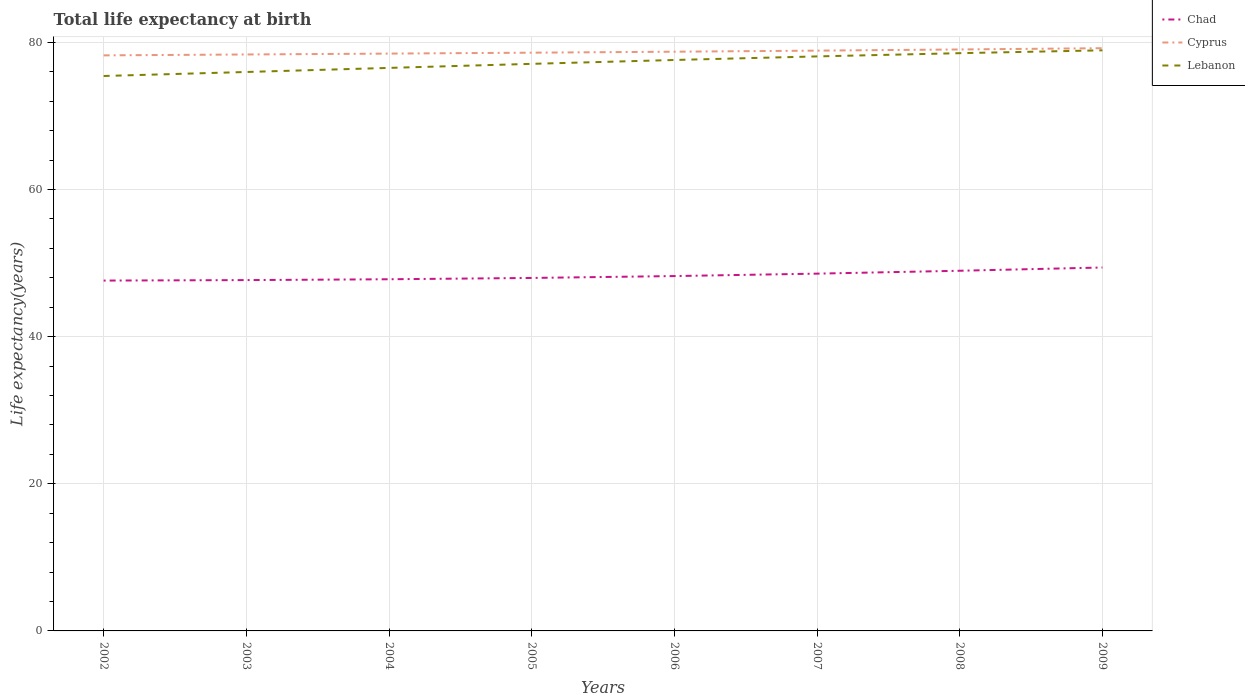Across all years, what is the maximum life expectancy at birth in in Lebanon?
Make the answer very short. 75.42. In which year was the life expectancy at birth in in Chad maximum?
Keep it short and to the point. 2002. What is the total life expectancy at birth in in Cyprus in the graph?
Keep it short and to the point. -0.85. What is the difference between the highest and the second highest life expectancy at birth in in Chad?
Your answer should be very brief. 1.78. What is the difference between the highest and the lowest life expectancy at birth in in Chad?
Keep it short and to the point. 3. Is the life expectancy at birth in in Lebanon strictly greater than the life expectancy at birth in in Cyprus over the years?
Offer a terse response. Yes. How many lines are there?
Keep it short and to the point. 3. What is the difference between two consecutive major ticks on the Y-axis?
Provide a short and direct response. 20. Where does the legend appear in the graph?
Offer a terse response. Top right. What is the title of the graph?
Your answer should be very brief. Total life expectancy at birth. Does "Cuba" appear as one of the legend labels in the graph?
Make the answer very short. No. What is the label or title of the Y-axis?
Keep it short and to the point. Life expectancy(years). What is the Life expectancy(years) in Chad in 2002?
Provide a short and direct response. 47.62. What is the Life expectancy(years) in Cyprus in 2002?
Your answer should be very brief. 78.22. What is the Life expectancy(years) in Lebanon in 2002?
Your answer should be compact. 75.42. What is the Life expectancy(years) of Chad in 2003?
Your answer should be very brief. 47.68. What is the Life expectancy(years) in Cyprus in 2003?
Provide a short and direct response. 78.35. What is the Life expectancy(years) of Lebanon in 2003?
Your answer should be very brief. 75.97. What is the Life expectancy(years) of Chad in 2004?
Ensure brevity in your answer.  47.8. What is the Life expectancy(years) of Cyprus in 2004?
Ensure brevity in your answer.  78.47. What is the Life expectancy(years) in Lebanon in 2004?
Your response must be concise. 76.52. What is the Life expectancy(years) of Chad in 2005?
Provide a short and direct response. 47.97. What is the Life expectancy(years) of Cyprus in 2005?
Your answer should be very brief. 78.59. What is the Life expectancy(years) of Lebanon in 2005?
Your answer should be compact. 77.07. What is the Life expectancy(years) of Chad in 2006?
Give a very brief answer. 48.23. What is the Life expectancy(years) of Cyprus in 2006?
Ensure brevity in your answer.  78.72. What is the Life expectancy(years) of Lebanon in 2006?
Give a very brief answer. 77.6. What is the Life expectancy(years) in Chad in 2007?
Ensure brevity in your answer.  48.56. What is the Life expectancy(years) of Cyprus in 2007?
Your answer should be very brief. 78.87. What is the Life expectancy(years) in Lebanon in 2007?
Make the answer very short. 78.08. What is the Life expectancy(years) of Chad in 2008?
Provide a succinct answer. 48.95. What is the Life expectancy(years) in Cyprus in 2008?
Your answer should be very brief. 79.03. What is the Life expectancy(years) of Lebanon in 2008?
Keep it short and to the point. 78.52. What is the Life expectancy(years) in Chad in 2009?
Provide a succinct answer. 49.39. What is the Life expectancy(years) in Cyprus in 2009?
Your response must be concise. 79.2. What is the Life expectancy(years) in Lebanon in 2009?
Ensure brevity in your answer.  78.91. Across all years, what is the maximum Life expectancy(years) in Chad?
Provide a succinct answer. 49.39. Across all years, what is the maximum Life expectancy(years) in Cyprus?
Make the answer very short. 79.2. Across all years, what is the maximum Life expectancy(years) of Lebanon?
Keep it short and to the point. 78.91. Across all years, what is the minimum Life expectancy(years) in Chad?
Offer a terse response. 47.62. Across all years, what is the minimum Life expectancy(years) of Cyprus?
Your response must be concise. 78.22. Across all years, what is the minimum Life expectancy(years) in Lebanon?
Keep it short and to the point. 75.42. What is the total Life expectancy(years) in Chad in the graph?
Offer a terse response. 386.2. What is the total Life expectancy(years) in Cyprus in the graph?
Your answer should be very brief. 629.44. What is the total Life expectancy(years) in Lebanon in the graph?
Offer a terse response. 618.09. What is the difference between the Life expectancy(years) of Chad in 2002 and that in 2003?
Provide a short and direct response. -0.07. What is the difference between the Life expectancy(years) in Cyprus in 2002 and that in 2003?
Your response must be concise. -0.12. What is the difference between the Life expectancy(years) in Lebanon in 2002 and that in 2003?
Keep it short and to the point. -0.55. What is the difference between the Life expectancy(years) of Chad in 2002 and that in 2004?
Give a very brief answer. -0.18. What is the difference between the Life expectancy(years) of Cyprus in 2002 and that in 2004?
Make the answer very short. -0.24. What is the difference between the Life expectancy(years) of Lebanon in 2002 and that in 2004?
Offer a terse response. -1.1. What is the difference between the Life expectancy(years) of Chad in 2002 and that in 2005?
Provide a short and direct response. -0.36. What is the difference between the Life expectancy(years) in Cyprus in 2002 and that in 2005?
Keep it short and to the point. -0.37. What is the difference between the Life expectancy(years) in Lebanon in 2002 and that in 2005?
Ensure brevity in your answer.  -1.65. What is the difference between the Life expectancy(years) in Chad in 2002 and that in 2006?
Your answer should be very brief. -0.61. What is the difference between the Life expectancy(years) of Cyprus in 2002 and that in 2006?
Provide a succinct answer. -0.5. What is the difference between the Life expectancy(years) of Lebanon in 2002 and that in 2006?
Provide a short and direct response. -2.18. What is the difference between the Life expectancy(years) of Chad in 2002 and that in 2007?
Provide a short and direct response. -0.94. What is the difference between the Life expectancy(years) of Cyprus in 2002 and that in 2007?
Your answer should be compact. -0.64. What is the difference between the Life expectancy(years) of Lebanon in 2002 and that in 2007?
Ensure brevity in your answer.  -2.66. What is the difference between the Life expectancy(years) of Chad in 2002 and that in 2008?
Offer a terse response. -1.34. What is the difference between the Life expectancy(years) in Cyprus in 2002 and that in 2008?
Your answer should be compact. -0.8. What is the difference between the Life expectancy(years) of Lebanon in 2002 and that in 2008?
Provide a short and direct response. -3.1. What is the difference between the Life expectancy(years) in Chad in 2002 and that in 2009?
Keep it short and to the point. -1.78. What is the difference between the Life expectancy(years) in Cyprus in 2002 and that in 2009?
Make the answer very short. -0.98. What is the difference between the Life expectancy(years) of Lebanon in 2002 and that in 2009?
Provide a short and direct response. -3.49. What is the difference between the Life expectancy(years) in Chad in 2003 and that in 2004?
Make the answer very short. -0.11. What is the difference between the Life expectancy(years) in Cyprus in 2003 and that in 2004?
Your answer should be compact. -0.12. What is the difference between the Life expectancy(years) of Lebanon in 2003 and that in 2004?
Keep it short and to the point. -0.56. What is the difference between the Life expectancy(years) in Chad in 2003 and that in 2005?
Ensure brevity in your answer.  -0.29. What is the difference between the Life expectancy(years) in Cyprus in 2003 and that in 2005?
Keep it short and to the point. -0.24. What is the difference between the Life expectancy(years) in Lebanon in 2003 and that in 2005?
Give a very brief answer. -1.11. What is the difference between the Life expectancy(years) in Chad in 2003 and that in 2006?
Offer a very short reply. -0.55. What is the difference between the Life expectancy(years) in Cyprus in 2003 and that in 2006?
Provide a succinct answer. -0.38. What is the difference between the Life expectancy(years) of Lebanon in 2003 and that in 2006?
Offer a very short reply. -1.63. What is the difference between the Life expectancy(years) of Chad in 2003 and that in 2007?
Your answer should be compact. -0.88. What is the difference between the Life expectancy(years) in Cyprus in 2003 and that in 2007?
Your answer should be compact. -0.52. What is the difference between the Life expectancy(years) of Lebanon in 2003 and that in 2007?
Ensure brevity in your answer.  -2.12. What is the difference between the Life expectancy(years) in Chad in 2003 and that in 2008?
Offer a very short reply. -1.27. What is the difference between the Life expectancy(years) of Cyprus in 2003 and that in 2008?
Keep it short and to the point. -0.68. What is the difference between the Life expectancy(years) in Lebanon in 2003 and that in 2008?
Offer a very short reply. -2.56. What is the difference between the Life expectancy(years) of Chad in 2003 and that in 2009?
Offer a very short reply. -1.71. What is the difference between the Life expectancy(years) of Cyprus in 2003 and that in 2009?
Provide a succinct answer. -0.85. What is the difference between the Life expectancy(years) of Lebanon in 2003 and that in 2009?
Give a very brief answer. -2.94. What is the difference between the Life expectancy(years) of Chad in 2004 and that in 2005?
Make the answer very short. -0.18. What is the difference between the Life expectancy(years) in Cyprus in 2004 and that in 2005?
Give a very brief answer. -0.12. What is the difference between the Life expectancy(years) of Lebanon in 2004 and that in 2005?
Offer a very short reply. -0.55. What is the difference between the Life expectancy(years) in Chad in 2004 and that in 2006?
Keep it short and to the point. -0.43. What is the difference between the Life expectancy(years) of Cyprus in 2004 and that in 2006?
Your answer should be very brief. -0.26. What is the difference between the Life expectancy(years) of Lebanon in 2004 and that in 2006?
Give a very brief answer. -1.08. What is the difference between the Life expectancy(years) in Chad in 2004 and that in 2007?
Make the answer very short. -0.76. What is the difference between the Life expectancy(years) in Cyprus in 2004 and that in 2007?
Provide a succinct answer. -0.4. What is the difference between the Life expectancy(years) of Lebanon in 2004 and that in 2007?
Offer a terse response. -1.56. What is the difference between the Life expectancy(years) of Chad in 2004 and that in 2008?
Make the answer very short. -1.16. What is the difference between the Life expectancy(years) in Cyprus in 2004 and that in 2008?
Offer a terse response. -0.56. What is the difference between the Life expectancy(years) in Lebanon in 2004 and that in 2008?
Give a very brief answer. -2. What is the difference between the Life expectancy(years) in Chad in 2004 and that in 2009?
Your response must be concise. -1.6. What is the difference between the Life expectancy(years) of Cyprus in 2004 and that in 2009?
Provide a short and direct response. -0.73. What is the difference between the Life expectancy(years) in Lebanon in 2004 and that in 2009?
Provide a short and direct response. -2.39. What is the difference between the Life expectancy(years) in Chad in 2005 and that in 2006?
Ensure brevity in your answer.  -0.26. What is the difference between the Life expectancy(years) in Cyprus in 2005 and that in 2006?
Your answer should be compact. -0.13. What is the difference between the Life expectancy(years) of Lebanon in 2005 and that in 2006?
Provide a short and direct response. -0.53. What is the difference between the Life expectancy(years) in Chad in 2005 and that in 2007?
Ensure brevity in your answer.  -0.59. What is the difference between the Life expectancy(years) in Cyprus in 2005 and that in 2007?
Provide a succinct answer. -0.28. What is the difference between the Life expectancy(years) in Lebanon in 2005 and that in 2007?
Offer a very short reply. -1.01. What is the difference between the Life expectancy(years) in Chad in 2005 and that in 2008?
Give a very brief answer. -0.98. What is the difference between the Life expectancy(years) in Cyprus in 2005 and that in 2008?
Offer a terse response. -0.44. What is the difference between the Life expectancy(years) of Lebanon in 2005 and that in 2008?
Make the answer very short. -1.45. What is the difference between the Life expectancy(years) in Chad in 2005 and that in 2009?
Make the answer very short. -1.42. What is the difference between the Life expectancy(years) in Cyprus in 2005 and that in 2009?
Your answer should be very brief. -0.61. What is the difference between the Life expectancy(years) in Lebanon in 2005 and that in 2009?
Offer a very short reply. -1.84. What is the difference between the Life expectancy(years) in Chad in 2006 and that in 2007?
Ensure brevity in your answer.  -0.33. What is the difference between the Life expectancy(years) in Cyprus in 2006 and that in 2007?
Your answer should be compact. -0.15. What is the difference between the Life expectancy(years) in Lebanon in 2006 and that in 2007?
Provide a short and direct response. -0.49. What is the difference between the Life expectancy(years) of Chad in 2006 and that in 2008?
Provide a short and direct response. -0.72. What is the difference between the Life expectancy(years) of Cyprus in 2006 and that in 2008?
Give a very brief answer. -0.3. What is the difference between the Life expectancy(years) in Lebanon in 2006 and that in 2008?
Keep it short and to the point. -0.93. What is the difference between the Life expectancy(years) of Chad in 2006 and that in 2009?
Offer a terse response. -1.16. What is the difference between the Life expectancy(years) of Cyprus in 2006 and that in 2009?
Your answer should be very brief. -0.48. What is the difference between the Life expectancy(years) in Lebanon in 2006 and that in 2009?
Keep it short and to the point. -1.31. What is the difference between the Life expectancy(years) of Chad in 2007 and that in 2008?
Your answer should be compact. -0.39. What is the difference between the Life expectancy(years) of Cyprus in 2007 and that in 2008?
Your answer should be very brief. -0.16. What is the difference between the Life expectancy(years) of Lebanon in 2007 and that in 2008?
Your answer should be very brief. -0.44. What is the difference between the Life expectancy(years) of Chad in 2007 and that in 2009?
Offer a very short reply. -0.83. What is the difference between the Life expectancy(years) of Cyprus in 2007 and that in 2009?
Provide a succinct answer. -0.33. What is the difference between the Life expectancy(years) of Lebanon in 2007 and that in 2009?
Offer a very short reply. -0.83. What is the difference between the Life expectancy(years) of Chad in 2008 and that in 2009?
Keep it short and to the point. -0.44. What is the difference between the Life expectancy(years) of Cyprus in 2008 and that in 2009?
Your response must be concise. -0.17. What is the difference between the Life expectancy(years) of Lebanon in 2008 and that in 2009?
Make the answer very short. -0.39. What is the difference between the Life expectancy(years) in Chad in 2002 and the Life expectancy(years) in Cyprus in 2003?
Offer a terse response. -30.73. What is the difference between the Life expectancy(years) in Chad in 2002 and the Life expectancy(years) in Lebanon in 2003?
Provide a succinct answer. -28.35. What is the difference between the Life expectancy(years) in Cyprus in 2002 and the Life expectancy(years) in Lebanon in 2003?
Offer a very short reply. 2.26. What is the difference between the Life expectancy(years) of Chad in 2002 and the Life expectancy(years) of Cyprus in 2004?
Ensure brevity in your answer.  -30.85. What is the difference between the Life expectancy(years) of Chad in 2002 and the Life expectancy(years) of Lebanon in 2004?
Make the answer very short. -28.91. What is the difference between the Life expectancy(years) in Cyprus in 2002 and the Life expectancy(years) in Lebanon in 2004?
Ensure brevity in your answer.  1.7. What is the difference between the Life expectancy(years) in Chad in 2002 and the Life expectancy(years) in Cyprus in 2005?
Keep it short and to the point. -30.97. What is the difference between the Life expectancy(years) of Chad in 2002 and the Life expectancy(years) of Lebanon in 2005?
Your answer should be compact. -29.46. What is the difference between the Life expectancy(years) in Cyprus in 2002 and the Life expectancy(years) in Lebanon in 2005?
Your answer should be very brief. 1.15. What is the difference between the Life expectancy(years) of Chad in 2002 and the Life expectancy(years) of Cyprus in 2006?
Ensure brevity in your answer.  -31.11. What is the difference between the Life expectancy(years) of Chad in 2002 and the Life expectancy(years) of Lebanon in 2006?
Your answer should be very brief. -29.98. What is the difference between the Life expectancy(years) in Cyprus in 2002 and the Life expectancy(years) in Lebanon in 2006?
Give a very brief answer. 0.63. What is the difference between the Life expectancy(years) in Chad in 2002 and the Life expectancy(years) in Cyprus in 2007?
Your answer should be compact. -31.25. What is the difference between the Life expectancy(years) of Chad in 2002 and the Life expectancy(years) of Lebanon in 2007?
Offer a very short reply. -30.47. What is the difference between the Life expectancy(years) of Cyprus in 2002 and the Life expectancy(years) of Lebanon in 2007?
Make the answer very short. 0.14. What is the difference between the Life expectancy(years) in Chad in 2002 and the Life expectancy(years) in Cyprus in 2008?
Your response must be concise. -31.41. What is the difference between the Life expectancy(years) of Chad in 2002 and the Life expectancy(years) of Lebanon in 2008?
Ensure brevity in your answer.  -30.91. What is the difference between the Life expectancy(years) of Cyprus in 2002 and the Life expectancy(years) of Lebanon in 2008?
Your answer should be compact. -0.3. What is the difference between the Life expectancy(years) in Chad in 2002 and the Life expectancy(years) in Cyprus in 2009?
Your response must be concise. -31.58. What is the difference between the Life expectancy(years) in Chad in 2002 and the Life expectancy(years) in Lebanon in 2009?
Offer a terse response. -31.29. What is the difference between the Life expectancy(years) in Cyprus in 2002 and the Life expectancy(years) in Lebanon in 2009?
Keep it short and to the point. -0.69. What is the difference between the Life expectancy(years) in Chad in 2003 and the Life expectancy(years) in Cyprus in 2004?
Offer a very short reply. -30.78. What is the difference between the Life expectancy(years) of Chad in 2003 and the Life expectancy(years) of Lebanon in 2004?
Provide a short and direct response. -28.84. What is the difference between the Life expectancy(years) in Cyprus in 2003 and the Life expectancy(years) in Lebanon in 2004?
Keep it short and to the point. 1.82. What is the difference between the Life expectancy(years) of Chad in 2003 and the Life expectancy(years) of Cyprus in 2005?
Provide a succinct answer. -30.91. What is the difference between the Life expectancy(years) of Chad in 2003 and the Life expectancy(years) of Lebanon in 2005?
Give a very brief answer. -29.39. What is the difference between the Life expectancy(years) of Cyprus in 2003 and the Life expectancy(years) of Lebanon in 2005?
Keep it short and to the point. 1.27. What is the difference between the Life expectancy(years) of Chad in 2003 and the Life expectancy(years) of Cyprus in 2006?
Offer a very short reply. -31.04. What is the difference between the Life expectancy(years) in Chad in 2003 and the Life expectancy(years) in Lebanon in 2006?
Keep it short and to the point. -29.91. What is the difference between the Life expectancy(years) in Cyprus in 2003 and the Life expectancy(years) in Lebanon in 2006?
Your response must be concise. 0.75. What is the difference between the Life expectancy(years) of Chad in 2003 and the Life expectancy(years) of Cyprus in 2007?
Make the answer very short. -31.19. What is the difference between the Life expectancy(years) of Chad in 2003 and the Life expectancy(years) of Lebanon in 2007?
Offer a terse response. -30.4. What is the difference between the Life expectancy(years) in Cyprus in 2003 and the Life expectancy(years) in Lebanon in 2007?
Ensure brevity in your answer.  0.26. What is the difference between the Life expectancy(years) of Chad in 2003 and the Life expectancy(years) of Cyprus in 2008?
Make the answer very short. -31.35. What is the difference between the Life expectancy(years) of Chad in 2003 and the Life expectancy(years) of Lebanon in 2008?
Offer a very short reply. -30.84. What is the difference between the Life expectancy(years) of Cyprus in 2003 and the Life expectancy(years) of Lebanon in 2008?
Give a very brief answer. -0.18. What is the difference between the Life expectancy(years) in Chad in 2003 and the Life expectancy(years) in Cyprus in 2009?
Your response must be concise. -31.52. What is the difference between the Life expectancy(years) in Chad in 2003 and the Life expectancy(years) in Lebanon in 2009?
Give a very brief answer. -31.23. What is the difference between the Life expectancy(years) of Cyprus in 2003 and the Life expectancy(years) of Lebanon in 2009?
Your answer should be very brief. -0.56. What is the difference between the Life expectancy(years) in Chad in 2004 and the Life expectancy(years) in Cyprus in 2005?
Your answer should be very brief. -30.79. What is the difference between the Life expectancy(years) in Chad in 2004 and the Life expectancy(years) in Lebanon in 2005?
Offer a terse response. -29.28. What is the difference between the Life expectancy(years) in Cyprus in 2004 and the Life expectancy(years) in Lebanon in 2005?
Give a very brief answer. 1.39. What is the difference between the Life expectancy(years) in Chad in 2004 and the Life expectancy(years) in Cyprus in 2006?
Keep it short and to the point. -30.93. What is the difference between the Life expectancy(years) in Chad in 2004 and the Life expectancy(years) in Lebanon in 2006?
Your answer should be compact. -29.8. What is the difference between the Life expectancy(years) of Cyprus in 2004 and the Life expectancy(years) of Lebanon in 2006?
Provide a short and direct response. 0.87. What is the difference between the Life expectancy(years) in Chad in 2004 and the Life expectancy(years) in Cyprus in 2007?
Your answer should be compact. -31.07. What is the difference between the Life expectancy(years) of Chad in 2004 and the Life expectancy(years) of Lebanon in 2007?
Offer a very short reply. -30.29. What is the difference between the Life expectancy(years) in Cyprus in 2004 and the Life expectancy(years) in Lebanon in 2007?
Offer a very short reply. 0.38. What is the difference between the Life expectancy(years) in Chad in 2004 and the Life expectancy(years) in Cyprus in 2008?
Make the answer very short. -31.23. What is the difference between the Life expectancy(years) in Chad in 2004 and the Life expectancy(years) in Lebanon in 2008?
Your answer should be very brief. -30.73. What is the difference between the Life expectancy(years) of Cyprus in 2004 and the Life expectancy(years) of Lebanon in 2008?
Give a very brief answer. -0.06. What is the difference between the Life expectancy(years) of Chad in 2004 and the Life expectancy(years) of Cyprus in 2009?
Provide a short and direct response. -31.4. What is the difference between the Life expectancy(years) in Chad in 2004 and the Life expectancy(years) in Lebanon in 2009?
Provide a succinct answer. -31.11. What is the difference between the Life expectancy(years) in Cyprus in 2004 and the Life expectancy(years) in Lebanon in 2009?
Keep it short and to the point. -0.44. What is the difference between the Life expectancy(years) in Chad in 2005 and the Life expectancy(years) in Cyprus in 2006?
Your answer should be compact. -30.75. What is the difference between the Life expectancy(years) in Chad in 2005 and the Life expectancy(years) in Lebanon in 2006?
Provide a short and direct response. -29.62. What is the difference between the Life expectancy(years) of Chad in 2005 and the Life expectancy(years) of Cyprus in 2007?
Ensure brevity in your answer.  -30.89. What is the difference between the Life expectancy(years) in Chad in 2005 and the Life expectancy(years) in Lebanon in 2007?
Your response must be concise. -30.11. What is the difference between the Life expectancy(years) of Cyprus in 2005 and the Life expectancy(years) of Lebanon in 2007?
Your answer should be very brief. 0.51. What is the difference between the Life expectancy(years) in Chad in 2005 and the Life expectancy(years) in Cyprus in 2008?
Your answer should be compact. -31.05. What is the difference between the Life expectancy(years) in Chad in 2005 and the Life expectancy(years) in Lebanon in 2008?
Keep it short and to the point. -30.55. What is the difference between the Life expectancy(years) of Cyprus in 2005 and the Life expectancy(years) of Lebanon in 2008?
Make the answer very short. 0.07. What is the difference between the Life expectancy(years) in Chad in 2005 and the Life expectancy(years) in Cyprus in 2009?
Your answer should be compact. -31.23. What is the difference between the Life expectancy(years) in Chad in 2005 and the Life expectancy(years) in Lebanon in 2009?
Offer a terse response. -30.94. What is the difference between the Life expectancy(years) in Cyprus in 2005 and the Life expectancy(years) in Lebanon in 2009?
Offer a terse response. -0.32. What is the difference between the Life expectancy(years) in Chad in 2006 and the Life expectancy(years) in Cyprus in 2007?
Offer a very short reply. -30.64. What is the difference between the Life expectancy(years) of Chad in 2006 and the Life expectancy(years) of Lebanon in 2007?
Give a very brief answer. -29.85. What is the difference between the Life expectancy(years) of Cyprus in 2006 and the Life expectancy(years) of Lebanon in 2007?
Your answer should be very brief. 0.64. What is the difference between the Life expectancy(years) of Chad in 2006 and the Life expectancy(years) of Cyprus in 2008?
Your answer should be very brief. -30.8. What is the difference between the Life expectancy(years) of Chad in 2006 and the Life expectancy(years) of Lebanon in 2008?
Provide a short and direct response. -30.29. What is the difference between the Life expectancy(years) in Cyprus in 2006 and the Life expectancy(years) in Lebanon in 2008?
Make the answer very short. 0.2. What is the difference between the Life expectancy(years) of Chad in 2006 and the Life expectancy(years) of Cyprus in 2009?
Your answer should be compact. -30.97. What is the difference between the Life expectancy(years) of Chad in 2006 and the Life expectancy(years) of Lebanon in 2009?
Your answer should be very brief. -30.68. What is the difference between the Life expectancy(years) of Cyprus in 2006 and the Life expectancy(years) of Lebanon in 2009?
Keep it short and to the point. -0.19. What is the difference between the Life expectancy(years) of Chad in 2007 and the Life expectancy(years) of Cyprus in 2008?
Your answer should be very brief. -30.47. What is the difference between the Life expectancy(years) of Chad in 2007 and the Life expectancy(years) of Lebanon in 2008?
Ensure brevity in your answer.  -29.96. What is the difference between the Life expectancy(years) of Cyprus in 2007 and the Life expectancy(years) of Lebanon in 2008?
Provide a succinct answer. 0.35. What is the difference between the Life expectancy(years) in Chad in 2007 and the Life expectancy(years) in Cyprus in 2009?
Provide a succinct answer. -30.64. What is the difference between the Life expectancy(years) of Chad in 2007 and the Life expectancy(years) of Lebanon in 2009?
Offer a very short reply. -30.35. What is the difference between the Life expectancy(years) in Cyprus in 2007 and the Life expectancy(years) in Lebanon in 2009?
Your answer should be compact. -0.04. What is the difference between the Life expectancy(years) of Chad in 2008 and the Life expectancy(years) of Cyprus in 2009?
Give a very brief answer. -30.25. What is the difference between the Life expectancy(years) of Chad in 2008 and the Life expectancy(years) of Lebanon in 2009?
Give a very brief answer. -29.96. What is the difference between the Life expectancy(years) in Cyprus in 2008 and the Life expectancy(years) in Lebanon in 2009?
Provide a succinct answer. 0.12. What is the average Life expectancy(years) in Chad per year?
Offer a very short reply. 48.28. What is the average Life expectancy(years) of Cyprus per year?
Your answer should be compact. 78.68. What is the average Life expectancy(years) of Lebanon per year?
Your answer should be very brief. 77.26. In the year 2002, what is the difference between the Life expectancy(years) of Chad and Life expectancy(years) of Cyprus?
Provide a short and direct response. -30.61. In the year 2002, what is the difference between the Life expectancy(years) in Chad and Life expectancy(years) in Lebanon?
Make the answer very short. -27.81. In the year 2002, what is the difference between the Life expectancy(years) in Cyprus and Life expectancy(years) in Lebanon?
Ensure brevity in your answer.  2.8. In the year 2003, what is the difference between the Life expectancy(years) in Chad and Life expectancy(years) in Cyprus?
Make the answer very short. -30.66. In the year 2003, what is the difference between the Life expectancy(years) of Chad and Life expectancy(years) of Lebanon?
Your response must be concise. -28.28. In the year 2003, what is the difference between the Life expectancy(years) in Cyprus and Life expectancy(years) in Lebanon?
Ensure brevity in your answer.  2.38. In the year 2004, what is the difference between the Life expectancy(years) of Chad and Life expectancy(years) of Cyprus?
Your response must be concise. -30.67. In the year 2004, what is the difference between the Life expectancy(years) of Chad and Life expectancy(years) of Lebanon?
Provide a succinct answer. -28.73. In the year 2004, what is the difference between the Life expectancy(years) of Cyprus and Life expectancy(years) of Lebanon?
Offer a very short reply. 1.94. In the year 2005, what is the difference between the Life expectancy(years) of Chad and Life expectancy(years) of Cyprus?
Give a very brief answer. -30.62. In the year 2005, what is the difference between the Life expectancy(years) of Chad and Life expectancy(years) of Lebanon?
Give a very brief answer. -29.1. In the year 2005, what is the difference between the Life expectancy(years) in Cyprus and Life expectancy(years) in Lebanon?
Give a very brief answer. 1.52. In the year 2006, what is the difference between the Life expectancy(years) in Chad and Life expectancy(years) in Cyprus?
Your answer should be very brief. -30.49. In the year 2006, what is the difference between the Life expectancy(years) in Chad and Life expectancy(years) in Lebanon?
Provide a succinct answer. -29.37. In the year 2006, what is the difference between the Life expectancy(years) of Cyprus and Life expectancy(years) of Lebanon?
Ensure brevity in your answer.  1.13. In the year 2007, what is the difference between the Life expectancy(years) in Chad and Life expectancy(years) in Cyprus?
Ensure brevity in your answer.  -30.31. In the year 2007, what is the difference between the Life expectancy(years) in Chad and Life expectancy(years) in Lebanon?
Provide a short and direct response. -29.52. In the year 2007, what is the difference between the Life expectancy(years) of Cyprus and Life expectancy(years) of Lebanon?
Your answer should be very brief. 0.79. In the year 2008, what is the difference between the Life expectancy(years) in Chad and Life expectancy(years) in Cyprus?
Your answer should be very brief. -30.08. In the year 2008, what is the difference between the Life expectancy(years) in Chad and Life expectancy(years) in Lebanon?
Your response must be concise. -29.57. In the year 2008, what is the difference between the Life expectancy(years) of Cyprus and Life expectancy(years) of Lebanon?
Offer a terse response. 0.51. In the year 2009, what is the difference between the Life expectancy(years) of Chad and Life expectancy(years) of Cyprus?
Make the answer very short. -29.81. In the year 2009, what is the difference between the Life expectancy(years) in Chad and Life expectancy(years) in Lebanon?
Your answer should be compact. -29.52. In the year 2009, what is the difference between the Life expectancy(years) in Cyprus and Life expectancy(years) in Lebanon?
Ensure brevity in your answer.  0.29. What is the ratio of the Life expectancy(years) of Lebanon in 2002 to that in 2004?
Provide a succinct answer. 0.99. What is the ratio of the Life expectancy(years) in Chad in 2002 to that in 2005?
Give a very brief answer. 0.99. What is the ratio of the Life expectancy(years) in Cyprus in 2002 to that in 2005?
Offer a terse response. 1. What is the ratio of the Life expectancy(years) in Lebanon in 2002 to that in 2005?
Make the answer very short. 0.98. What is the ratio of the Life expectancy(years) in Chad in 2002 to that in 2006?
Give a very brief answer. 0.99. What is the ratio of the Life expectancy(years) in Chad in 2002 to that in 2007?
Keep it short and to the point. 0.98. What is the ratio of the Life expectancy(years) of Cyprus in 2002 to that in 2007?
Make the answer very short. 0.99. What is the ratio of the Life expectancy(years) in Lebanon in 2002 to that in 2007?
Ensure brevity in your answer.  0.97. What is the ratio of the Life expectancy(years) in Chad in 2002 to that in 2008?
Ensure brevity in your answer.  0.97. What is the ratio of the Life expectancy(years) in Lebanon in 2002 to that in 2008?
Offer a very short reply. 0.96. What is the ratio of the Life expectancy(years) of Lebanon in 2002 to that in 2009?
Give a very brief answer. 0.96. What is the ratio of the Life expectancy(years) of Cyprus in 2003 to that in 2004?
Provide a short and direct response. 1. What is the ratio of the Life expectancy(years) in Lebanon in 2003 to that in 2004?
Keep it short and to the point. 0.99. What is the ratio of the Life expectancy(years) in Chad in 2003 to that in 2005?
Give a very brief answer. 0.99. What is the ratio of the Life expectancy(years) in Cyprus in 2003 to that in 2005?
Keep it short and to the point. 1. What is the ratio of the Life expectancy(years) of Lebanon in 2003 to that in 2005?
Provide a short and direct response. 0.99. What is the ratio of the Life expectancy(years) of Cyprus in 2003 to that in 2006?
Make the answer very short. 1. What is the ratio of the Life expectancy(years) in Lebanon in 2003 to that in 2006?
Your answer should be very brief. 0.98. What is the ratio of the Life expectancy(years) of Chad in 2003 to that in 2007?
Your response must be concise. 0.98. What is the ratio of the Life expectancy(years) of Cyprus in 2003 to that in 2007?
Provide a short and direct response. 0.99. What is the ratio of the Life expectancy(years) of Lebanon in 2003 to that in 2007?
Your answer should be very brief. 0.97. What is the ratio of the Life expectancy(years) in Chad in 2003 to that in 2008?
Provide a short and direct response. 0.97. What is the ratio of the Life expectancy(years) in Cyprus in 2003 to that in 2008?
Offer a terse response. 0.99. What is the ratio of the Life expectancy(years) of Lebanon in 2003 to that in 2008?
Provide a succinct answer. 0.97. What is the ratio of the Life expectancy(years) of Chad in 2003 to that in 2009?
Your answer should be very brief. 0.97. What is the ratio of the Life expectancy(years) in Cyprus in 2003 to that in 2009?
Your response must be concise. 0.99. What is the ratio of the Life expectancy(years) of Lebanon in 2003 to that in 2009?
Offer a very short reply. 0.96. What is the ratio of the Life expectancy(years) of Lebanon in 2004 to that in 2005?
Give a very brief answer. 0.99. What is the ratio of the Life expectancy(years) in Chad in 2004 to that in 2006?
Offer a terse response. 0.99. What is the ratio of the Life expectancy(years) of Lebanon in 2004 to that in 2006?
Give a very brief answer. 0.99. What is the ratio of the Life expectancy(years) of Chad in 2004 to that in 2007?
Your response must be concise. 0.98. What is the ratio of the Life expectancy(years) of Cyprus in 2004 to that in 2007?
Make the answer very short. 0.99. What is the ratio of the Life expectancy(years) in Lebanon in 2004 to that in 2007?
Give a very brief answer. 0.98. What is the ratio of the Life expectancy(years) in Chad in 2004 to that in 2008?
Provide a succinct answer. 0.98. What is the ratio of the Life expectancy(years) in Lebanon in 2004 to that in 2008?
Provide a short and direct response. 0.97. What is the ratio of the Life expectancy(years) of Lebanon in 2004 to that in 2009?
Your response must be concise. 0.97. What is the ratio of the Life expectancy(years) in Chad in 2005 to that in 2006?
Offer a very short reply. 0.99. What is the ratio of the Life expectancy(years) of Lebanon in 2005 to that in 2006?
Your answer should be compact. 0.99. What is the ratio of the Life expectancy(years) in Chad in 2005 to that in 2007?
Offer a very short reply. 0.99. What is the ratio of the Life expectancy(years) of Cyprus in 2005 to that in 2007?
Offer a terse response. 1. What is the ratio of the Life expectancy(years) of Lebanon in 2005 to that in 2007?
Give a very brief answer. 0.99. What is the ratio of the Life expectancy(years) of Chad in 2005 to that in 2008?
Keep it short and to the point. 0.98. What is the ratio of the Life expectancy(years) in Cyprus in 2005 to that in 2008?
Provide a short and direct response. 0.99. What is the ratio of the Life expectancy(years) of Lebanon in 2005 to that in 2008?
Provide a short and direct response. 0.98. What is the ratio of the Life expectancy(years) of Chad in 2005 to that in 2009?
Offer a very short reply. 0.97. What is the ratio of the Life expectancy(years) of Lebanon in 2005 to that in 2009?
Your answer should be compact. 0.98. What is the ratio of the Life expectancy(years) in Chad in 2006 to that in 2007?
Offer a terse response. 0.99. What is the ratio of the Life expectancy(years) in Cyprus in 2006 to that in 2007?
Provide a short and direct response. 1. What is the ratio of the Life expectancy(years) of Lebanon in 2006 to that in 2007?
Provide a short and direct response. 0.99. What is the ratio of the Life expectancy(years) of Chad in 2006 to that in 2008?
Your answer should be very brief. 0.99. What is the ratio of the Life expectancy(years) of Lebanon in 2006 to that in 2008?
Make the answer very short. 0.99. What is the ratio of the Life expectancy(years) in Chad in 2006 to that in 2009?
Give a very brief answer. 0.98. What is the ratio of the Life expectancy(years) of Lebanon in 2006 to that in 2009?
Keep it short and to the point. 0.98. What is the ratio of the Life expectancy(years) in Lebanon in 2007 to that in 2008?
Provide a succinct answer. 0.99. What is the ratio of the Life expectancy(years) of Chad in 2007 to that in 2009?
Your answer should be compact. 0.98. What is the ratio of the Life expectancy(years) in Cyprus in 2007 to that in 2009?
Provide a short and direct response. 1. What is the difference between the highest and the second highest Life expectancy(years) of Chad?
Keep it short and to the point. 0.44. What is the difference between the highest and the second highest Life expectancy(years) of Cyprus?
Your response must be concise. 0.17. What is the difference between the highest and the second highest Life expectancy(years) in Lebanon?
Your answer should be very brief. 0.39. What is the difference between the highest and the lowest Life expectancy(years) in Chad?
Give a very brief answer. 1.78. What is the difference between the highest and the lowest Life expectancy(years) of Cyprus?
Ensure brevity in your answer.  0.98. What is the difference between the highest and the lowest Life expectancy(years) in Lebanon?
Offer a terse response. 3.49. 